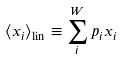Convert formula to latex. <formula><loc_0><loc_0><loc_500><loc_500>\langle x _ { i } \rangle _ { \text {lin} } \equiv \sum _ { i } ^ { W } p _ { i } x _ { i }</formula> 